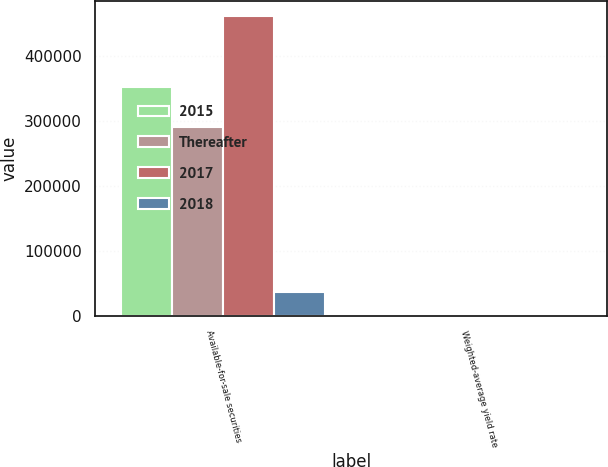<chart> <loc_0><loc_0><loc_500><loc_500><stacked_bar_chart><ecel><fcel>Available-for-sale securities<fcel>Weighted-average yield rate<nl><fcel>2015<fcel>352279<fcel>1.48<nl><fcel>Thereafter<fcel>290359<fcel>1.37<nl><fcel>2017<fcel>462073<fcel>0.57<nl><fcel>2018<fcel>36958<fcel>0.81<nl></chart> 